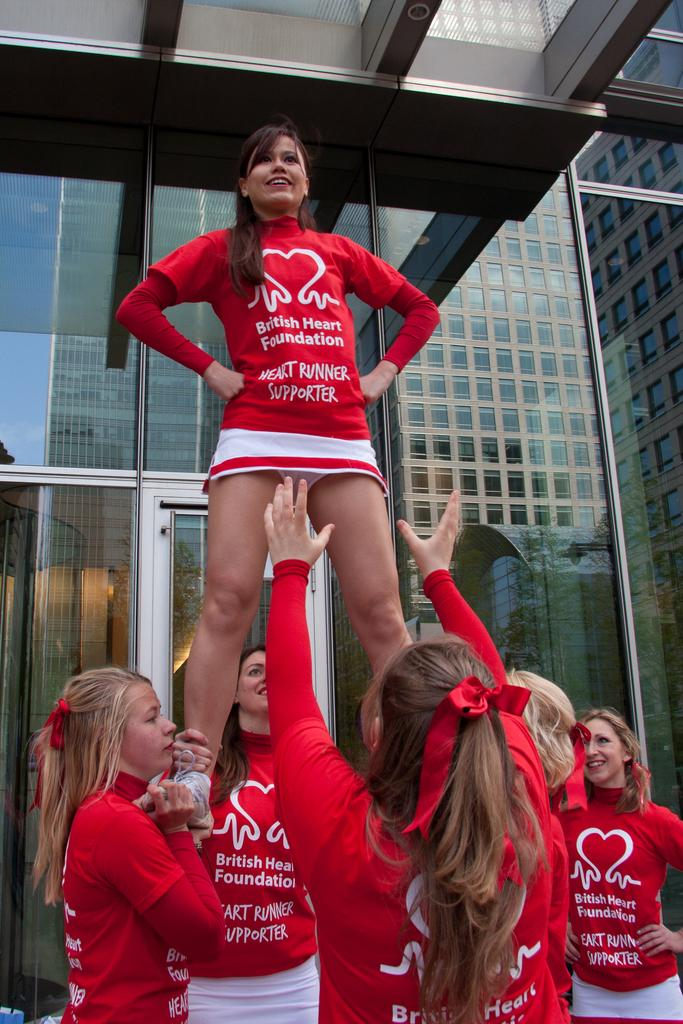<image>
Create a compact narrative representing the image presented. A group of girls wear red shirts that say British Heart Foundation. 